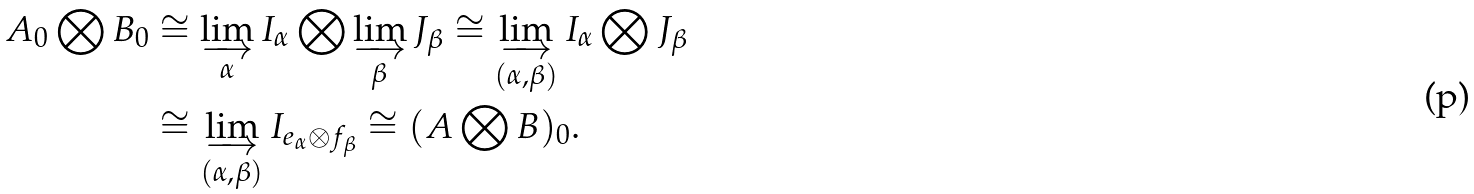Convert formula to latex. <formula><loc_0><loc_0><loc_500><loc_500>A _ { 0 } \bigotimes B _ { 0 } & \cong \varinjlim _ { \alpha } I _ { \alpha } \bigotimes \varinjlim _ { \beta } J _ { \beta } \cong \varinjlim _ { ( \alpha , \beta ) } I _ { \alpha } \bigotimes J _ { \beta } \\ & \cong \varinjlim _ { ( \alpha , \beta ) } I _ { e _ { \alpha } \otimes f _ { \beta } } \cong ( A \bigotimes B ) _ { 0 } .</formula> 